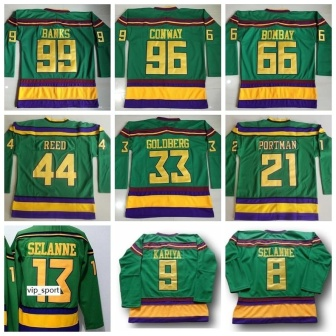Analyze the image in a comprehensive and detailed manner. The image showcases a collection of nine green hockey jerseys, each featuring bold yellow and purple stripes. The jerseys are meticulously arranged on a clean white wall in a 3x3 grid layout. Each jersey is distinct, displaying a unique name and number on the back, indicative of individual players. 

Starting from the top left, the first jersey is assigned to 'Banks' with the number 99, followed by 'Conway' with the number 96, and 'Bombay' with the number 66. 

In the middle row, from left to right, the first jersey belongs to 'Reed' with the number 44. Centrally positioned in this row is 'Goldberg's' jersey, marked with the number 33. The last one in this row is 'Portman's' jersey, displaying the number 21. 

The bottom row begins with a jersey for 'Selanne', bearing the number 17, which also includes a logo that reads 'vip.sports'. The middle jersey in this row belongs to 'Kariya' with the number 9. The final jersey, completing the grid, is another one for 'Selanne' but this time with the number 8. 

The vibrant colors and unique identifiers on each jersey make for an eye-catching and well-organized display, highlighted against the stark white background. 